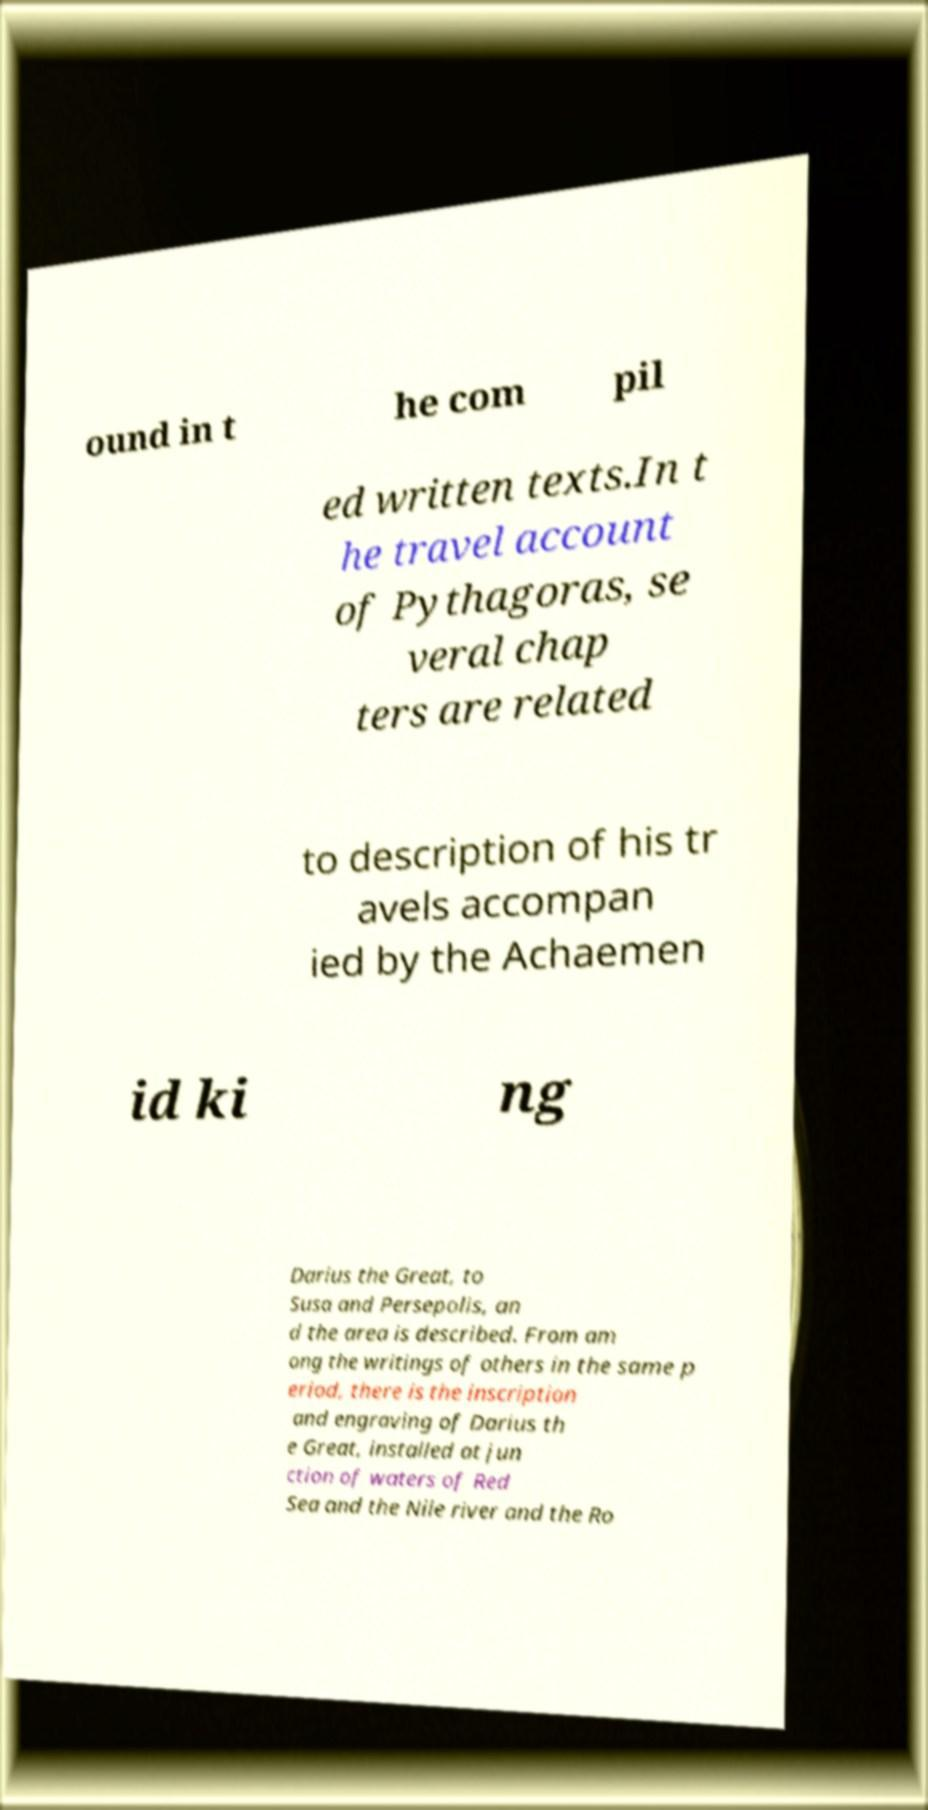Can you read and provide the text displayed in the image?This photo seems to have some interesting text. Can you extract and type it out for me? ound in t he com pil ed written texts.In t he travel account of Pythagoras, se veral chap ters are related to description of his tr avels accompan ied by the Achaemen id ki ng Darius the Great, to Susa and Persepolis, an d the area is described. From am ong the writings of others in the same p eriod, there is the inscription and engraving of Darius th e Great, installed at jun ction of waters of Red Sea and the Nile river and the Ro 